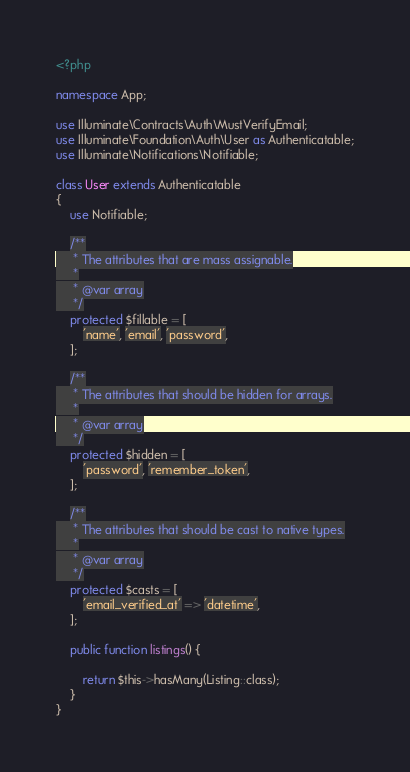<code> <loc_0><loc_0><loc_500><loc_500><_PHP_><?php

namespace App;

use Illuminate\Contracts\Auth\MustVerifyEmail;
use Illuminate\Foundation\Auth\User as Authenticatable;
use Illuminate\Notifications\Notifiable;

class User extends Authenticatable
{
    use Notifiable;

    /**
     * The attributes that are mass assignable.
     *
     * @var array
     */
    protected $fillable = [
        'name', 'email', 'password',
    ];

    /**
     * The attributes that should be hidden for arrays.
     *
     * @var array
     */
    protected $hidden = [
        'password', 'remember_token',
    ];

    /**
     * The attributes that should be cast to native types.
     *
     * @var array
     */
    protected $casts = [
        'email_verified_at' => 'datetime',
    ];

    public function listings() {

        return $this->hasMany(Listing::class);
    }
}
</code> 